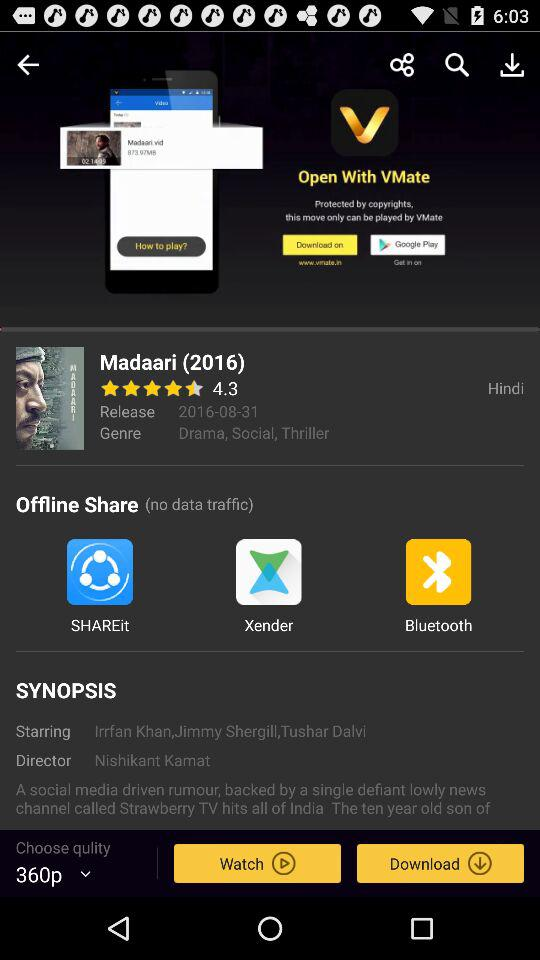What is the rating? The rating is 4.3. 